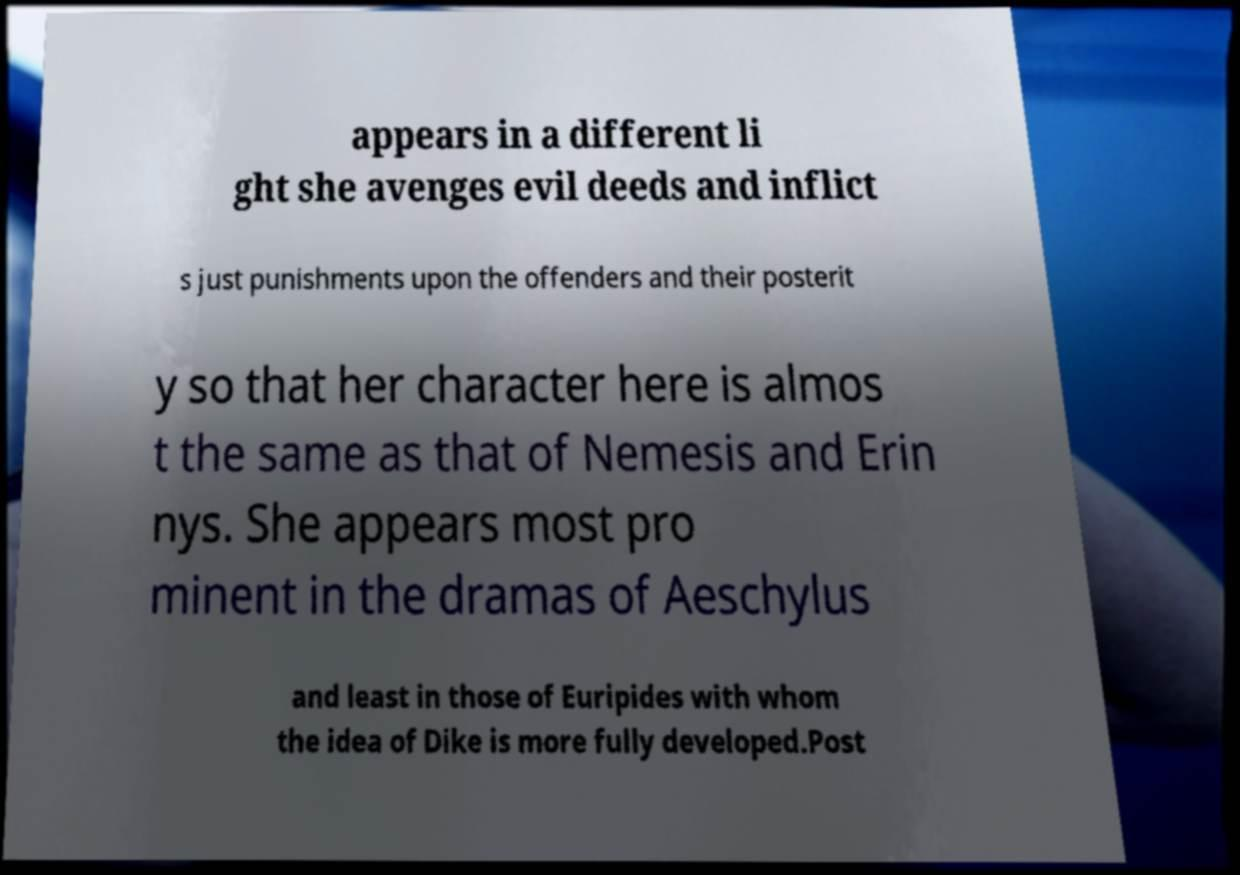Could you assist in decoding the text presented in this image and type it out clearly? appears in a different li ght she avenges evil deeds and inflict s just punishments upon the offenders and their posterit y so that her character here is almos t the same as that of Nemesis and Erin nys. She appears most pro minent in the dramas of Aeschylus and least in those of Euripides with whom the idea of Dike is more fully developed.Post 